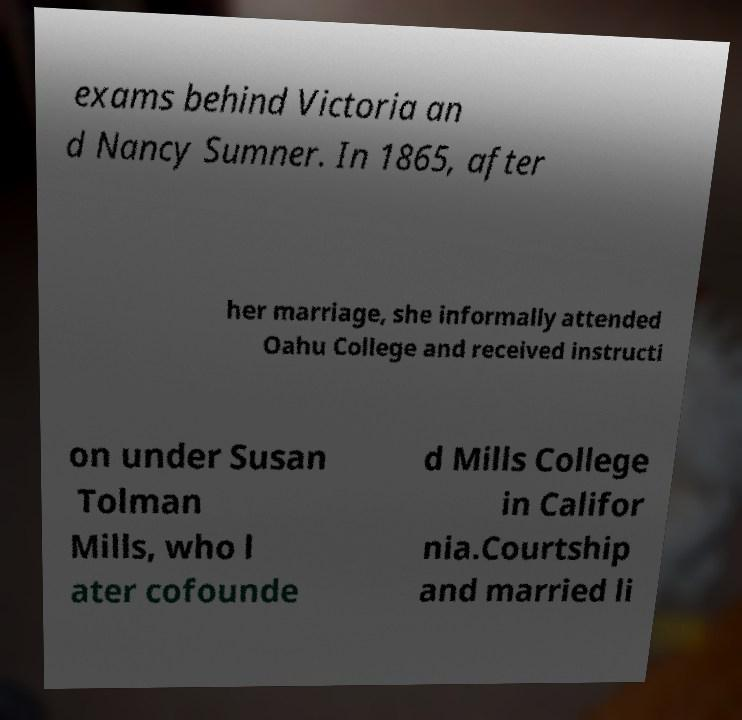Please read and relay the text visible in this image. What does it say? exams behind Victoria an d Nancy Sumner. In 1865, after her marriage, she informally attended Oahu College and received instructi on under Susan Tolman Mills, who l ater cofounde d Mills College in Califor nia.Courtship and married li 